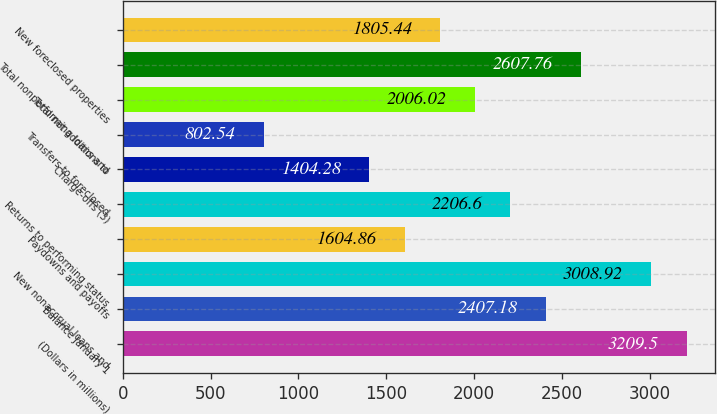Convert chart to OTSL. <chart><loc_0><loc_0><loc_500><loc_500><bar_chart><fcel>(Dollars in millions)<fcel>Balance January 1<fcel>New nonaccrual loans and<fcel>Paydowns and payoffs<fcel>Returns to performing status<fcel>Charge-offs (3)<fcel>Transfers to foreclosed<fcel>Total net additions to<fcel>Total nonperforming loans and<fcel>New foreclosed properties<nl><fcel>3209.5<fcel>2407.18<fcel>3008.92<fcel>1604.86<fcel>2206.6<fcel>1404.28<fcel>802.54<fcel>2006.02<fcel>2607.76<fcel>1805.44<nl></chart> 